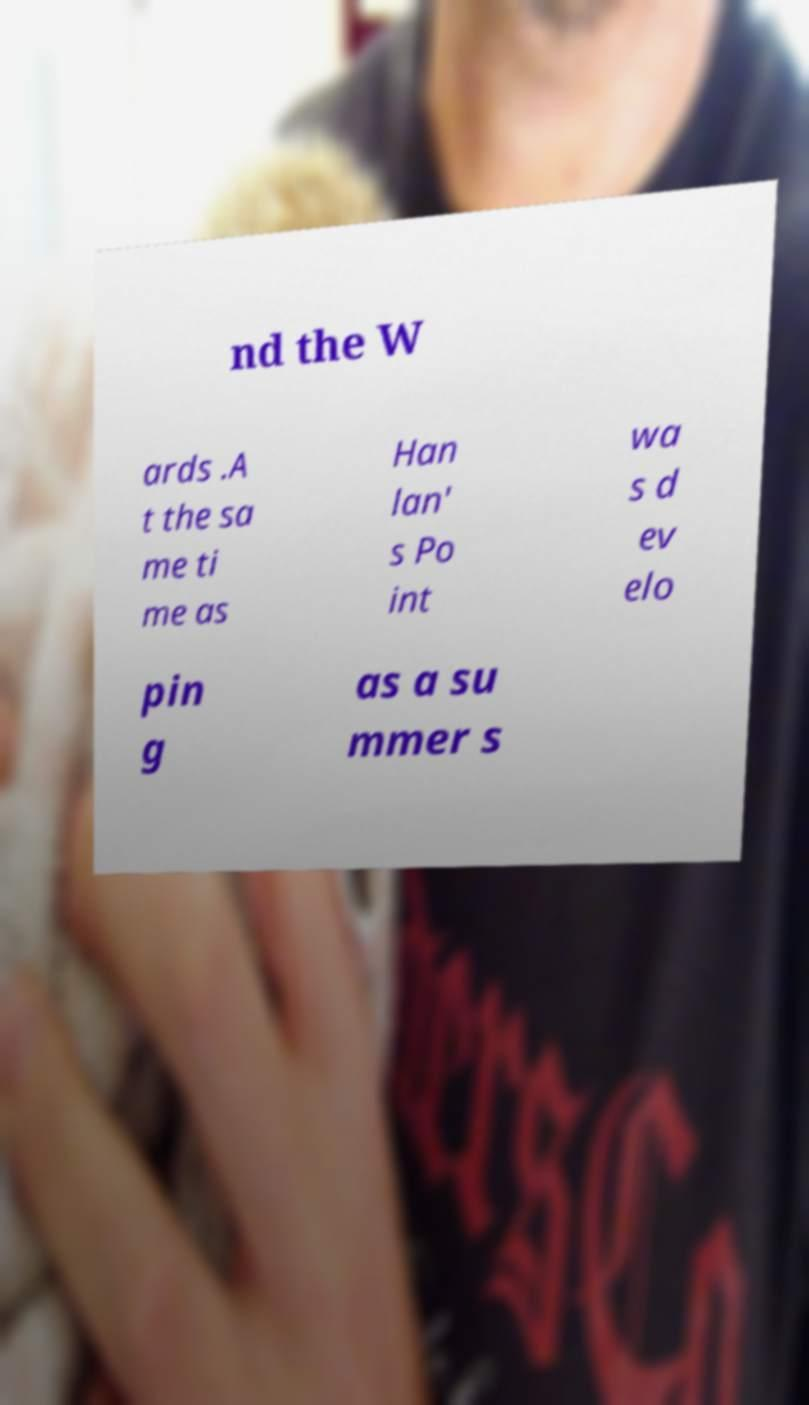I need the written content from this picture converted into text. Can you do that? nd the W ards .A t the sa me ti me as Han lan' s Po int wa s d ev elo pin g as a su mmer s 